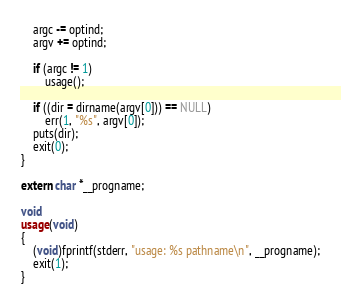<code> <loc_0><loc_0><loc_500><loc_500><_C_>	argc -= optind;
	argv += optind;

	if (argc != 1)
		usage();

	if ((dir = dirname(argv[0])) == NULL)
		err(1, "%s", argv[0]);
	puts(dir);
	exit(0);
}

extern char *__progname;

void
usage(void)
{
	(void)fprintf(stderr, "usage: %s pathname\n", __progname);
	exit(1);
}
</code> 